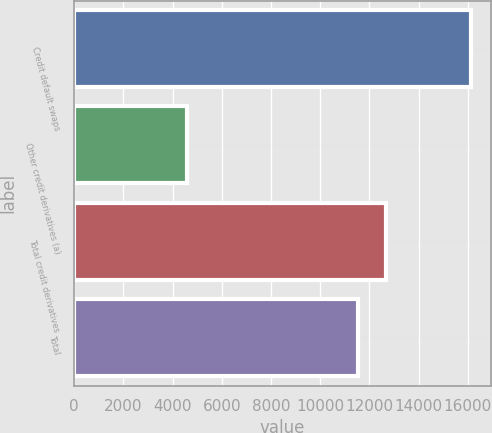Convert chart. <chart><loc_0><loc_0><loc_500><loc_500><bar_chart><fcel>Credit default swaps<fcel>Other credit derivatives (a)<fcel>Total credit derivatives<fcel>Total<nl><fcel>16130<fcel>4580<fcel>12675<fcel>11520<nl></chart> 